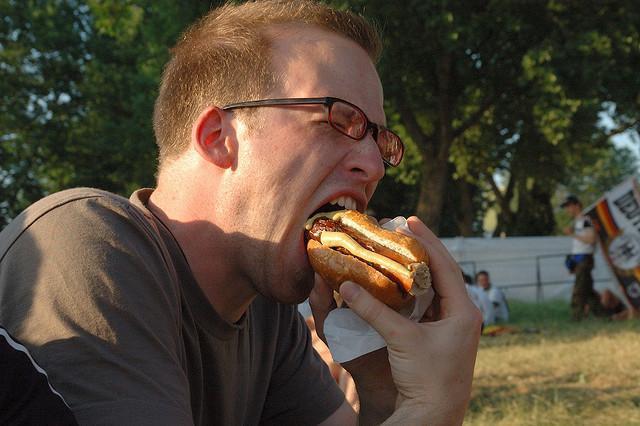How many people are visible?
Give a very brief answer. 2. 